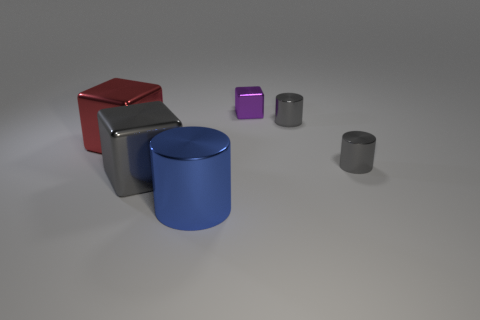Add 2 large red things. How many objects exist? 8 Subtract 1 blue cylinders. How many objects are left? 5 Subtract all purple metal cubes. Subtract all cyan spheres. How many objects are left? 5 Add 5 big metal cylinders. How many big metal cylinders are left? 6 Add 1 large gray blocks. How many large gray blocks exist? 2 